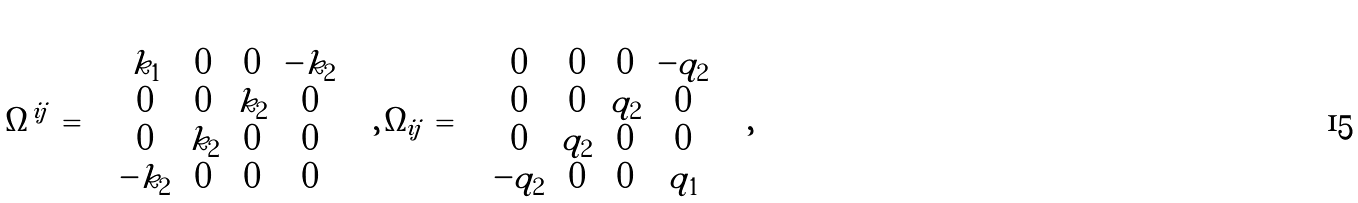Convert formula to latex. <formula><loc_0><loc_0><loc_500><loc_500>\Omega ^ { i j } \, = \, \left ( \begin{array} { c c c c } k _ { 1 } & 0 & 0 & - k _ { 2 } \\ 0 & 0 & k _ { 2 } & 0 \\ 0 & k _ { 2 } & 0 & 0 \\ - k _ { 2 } & 0 & 0 & 0 \end{array} \right ) \, , \, \Omega _ { i j } \, = \, \left ( \begin{array} { c c c c } 0 & 0 & 0 & - q _ { 2 } \\ 0 & 0 & q _ { 2 } & 0 \\ 0 & q _ { 2 } & 0 & 0 \\ - q _ { 2 } & 0 & 0 & q _ { 1 } \end{array} \right ) \, ,</formula> 